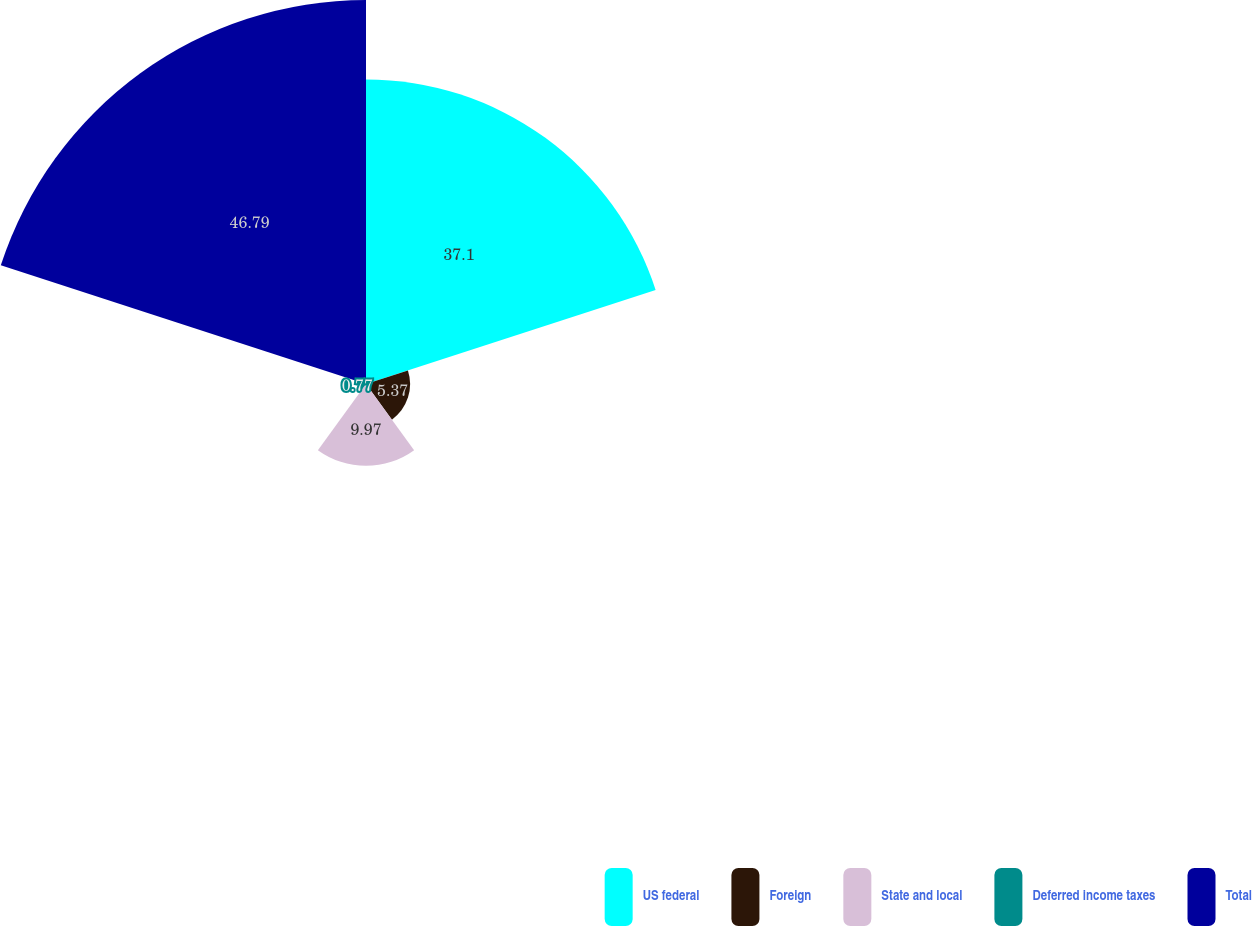Convert chart. <chart><loc_0><loc_0><loc_500><loc_500><pie_chart><fcel>US federal<fcel>Foreign<fcel>State and local<fcel>Deferred income taxes<fcel>Total<nl><fcel>37.1%<fcel>5.37%<fcel>9.97%<fcel>0.77%<fcel>46.78%<nl></chart> 